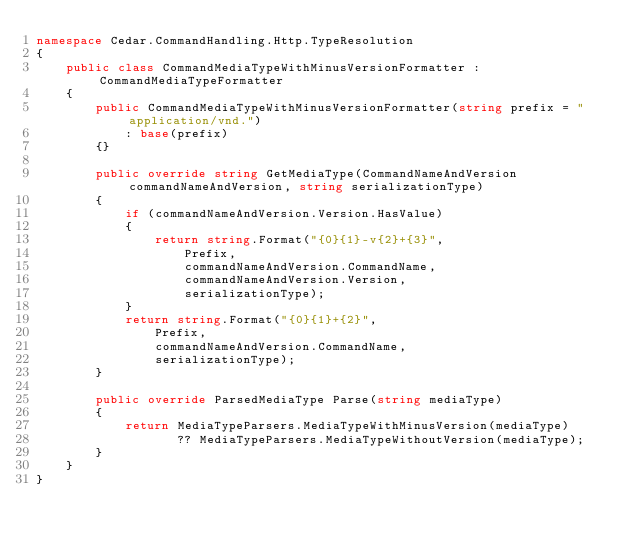<code> <loc_0><loc_0><loc_500><loc_500><_C#_>namespace Cedar.CommandHandling.Http.TypeResolution
{
    public class CommandMediaTypeWithMinusVersionFormatter : CommandMediaTypeFormatter
    {
        public CommandMediaTypeWithMinusVersionFormatter(string prefix = "application/vnd.")
            : base(prefix)
        {}

        public override string GetMediaType(CommandNameAndVersion commandNameAndVersion, string serializationType)
        {
            if (commandNameAndVersion.Version.HasValue)
            {
                return string.Format("{0}{1}-v{2}+{3}",
                    Prefix,
                    commandNameAndVersion.CommandName,
                    commandNameAndVersion.Version,
                    serializationType);
            }
            return string.Format("{0}{1}+{2}",
                Prefix,
                commandNameAndVersion.CommandName,
                serializationType);
        }

        public override ParsedMediaType Parse(string mediaType)
        {
            return MediaTypeParsers.MediaTypeWithMinusVersion(mediaType)
                   ?? MediaTypeParsers.MediaTypeWithoutVersion(mediaType);
        }
    }
}</code> 